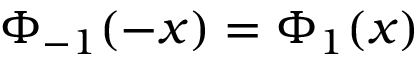Convert formula to latex. <formula><loc_0><loc_0><loc_500><loc_500>\Phi _ { - 1 } ( - x ) = \Phi _ { 1 } ( x )</formula> 